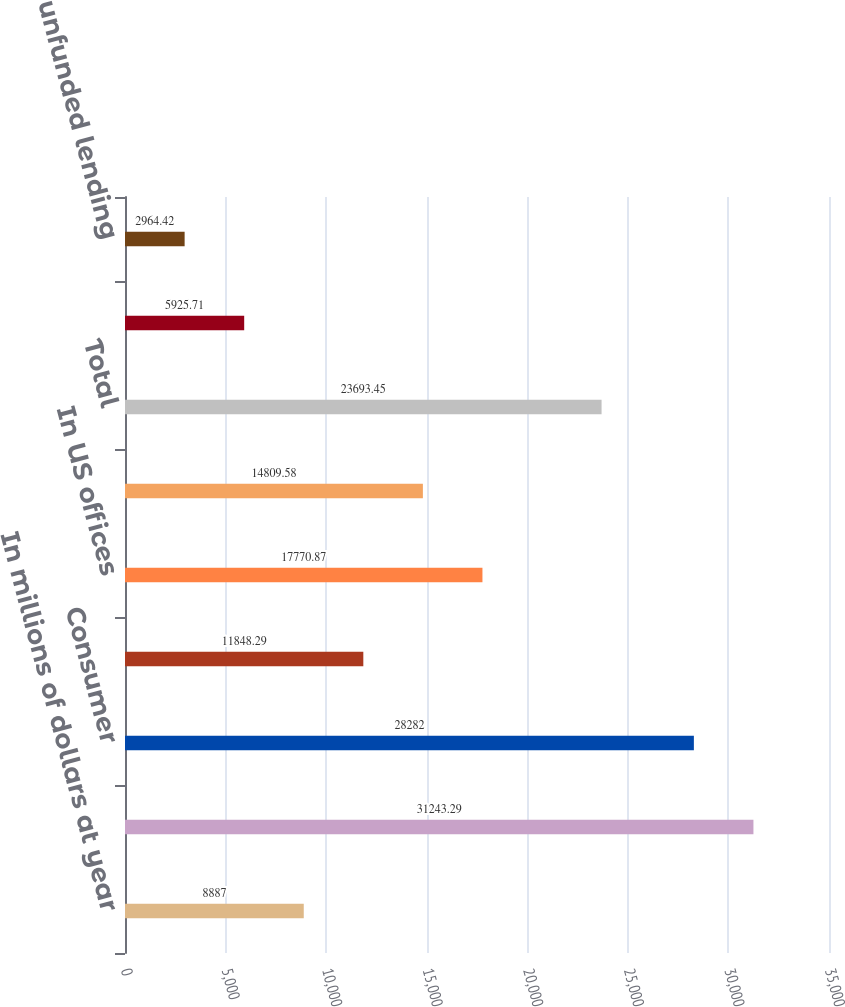<chart> <loc_0><loc_0><loc_500><loc_500><bar_chart><fcel>In millions of dollars at year<fcel>Allowance for loan losses at<fcel>Consumer<fcel>Corporate<fcel>In US offices<fcel>In offices outside the US<fcel>Total<fcel>Other-net (2)<fcel>Allowance for unfunded lending<nl><fcel>8887<fcel>31243.3<fcel>28282<fcel>11848.3<fcel>17770.9<fcel>14809.6<fcel>23693.5<fcel>5925.71<fcel>2964.42<nl></chart> 